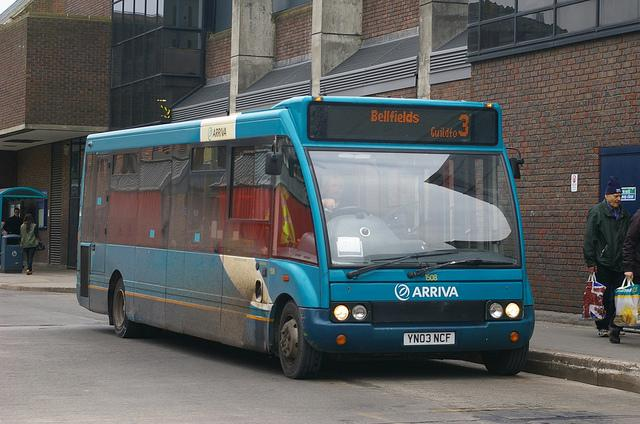How was the man able to get the plastic bags he is carrying? made purchases 